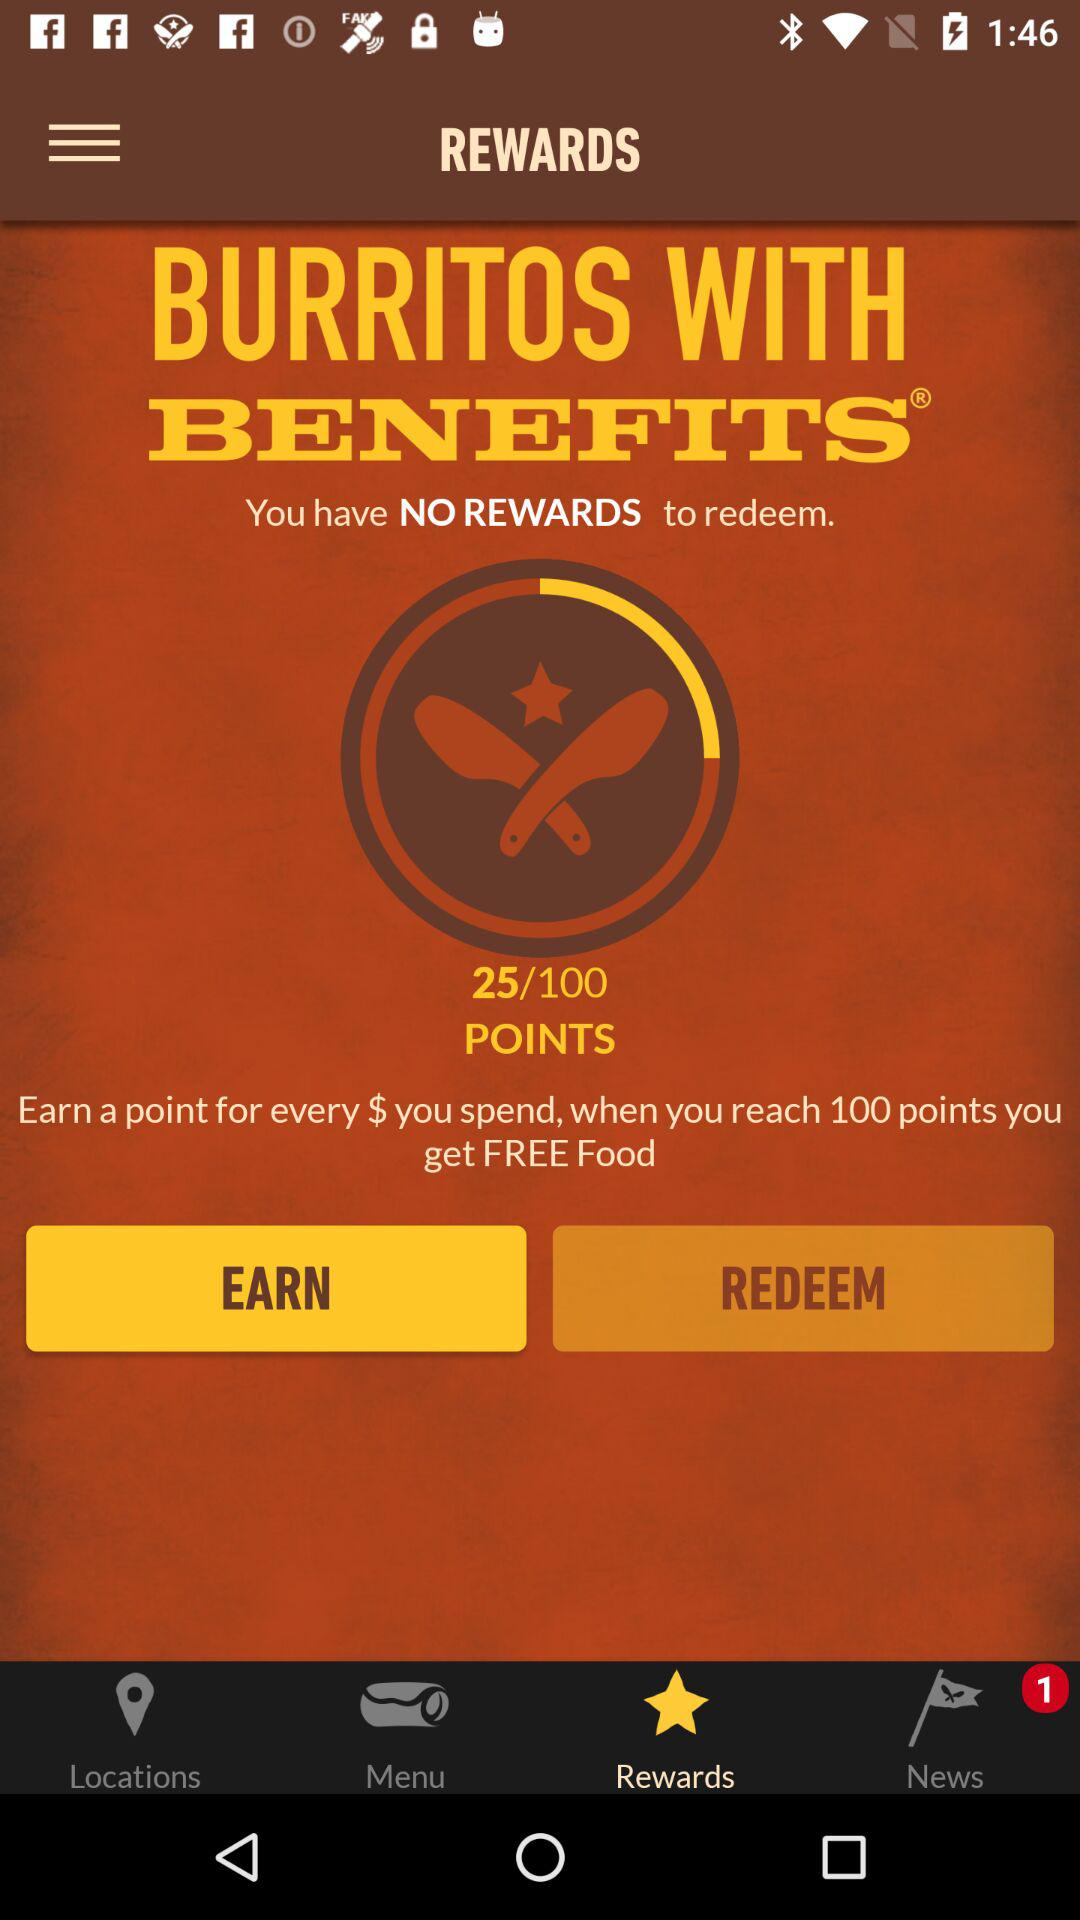How many points are required to earn?
When the provided information is insufficient, respond with <no answer>. <no answer> 